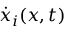Convert formula to latex. <formula><loc_0><loc_0><loc_500><loc_500>\dot { x } _ { i } ( x , t )</formula> 